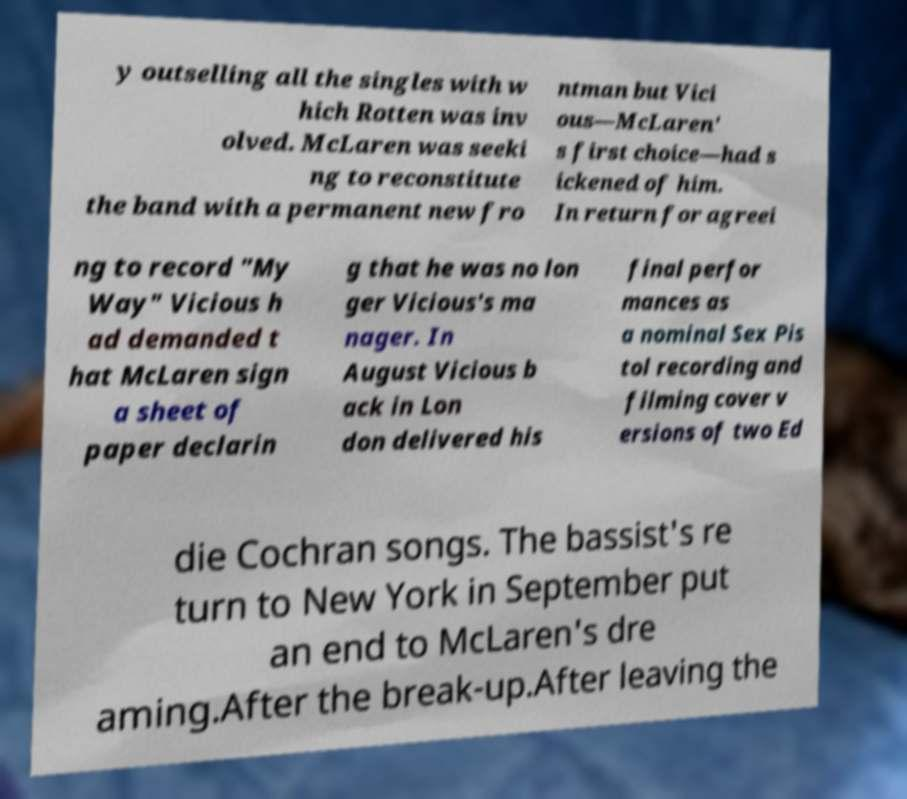Could you assist in decoding the text presented in this image and type it out clearly? y outselling all the singles with w hich Rotten was inv olved. McLaren was seeki ng to reconstitute the band with a permanent new fro ntman but Vici ous—McLaren' s first choice—had s ickened of him. In return for agreei ng to record "My Way" Vicious h ad demanded t hat McLaren sign a sheet of paper declarin g that he was no lon ger Vicious's ma nager. In August Vicious b ack in Lon don delivered his final perfor mances as a nominal Sex Pis tol recording and filming cover v ersions of two Ed die Cochran songs. The bassist's re turn to New York in September put an end to McLaren's dre aming.After the break-up.After leaving the 